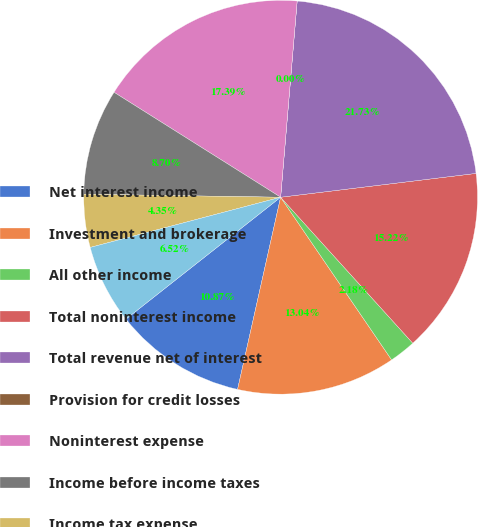Convert chart. <chart><loc_0><loc_0><loc_500><loc_500><pie_chart><fcel>Net interest income<fcel>Investment and brokerage<fcel>All other income<fcel>Total noninterest income<fcel>Total revenue net of interest<fcel>Provision for credit losses<fcel>Noninterest expense<fcel>Income before income taxes<fcel>Income tax expense<fcel>Net income<nl><fcel>10.87%<fcel>13.04%<fcel>2.18%<fcel>15.22%<fcel>21.73%<fcel>0.0%<fcel>17.39%<fcel>8.7%<fcel>4.35%<fcel>6.52%<nl></chart> 